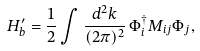Convert formula to latex. <formula><loc_0><loc_0><loc_500><loc_500>H ^ { \prime } _ { b } = \frac { 1 } { 2 } \int \frac { d ^ { 2 } k } { ( 2 \pi ) ^ { 2 } } \, \Phi _ { i } ^ { \dag } M _ { i j } \Phi _ { j } ,</formula> 